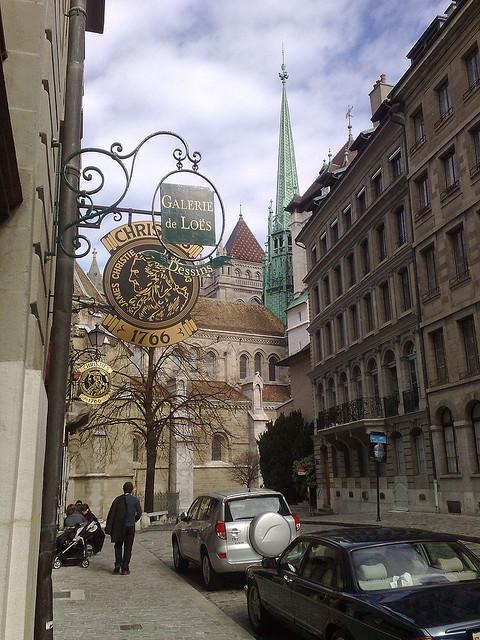What does the sign over the door say?
Short answer required. Galerie de los. How many vehicles do you see?
Short answer required. 2. How many vehicles are in the photo?
Quick response, please. 2. How many stories tall is the building on the right?
Write a very short answer. 5. How many cars are in the scene?
Short answer required. 2. Are there any people in the picture?
Give a very brief answer. Yes. How many items are on the top of the car?
Be succinct. 0. Roughly speaking, what decade did this car first  see use?
Be succinct. 1990. What year is on the rounded sign?
Be succinct. 1766. 